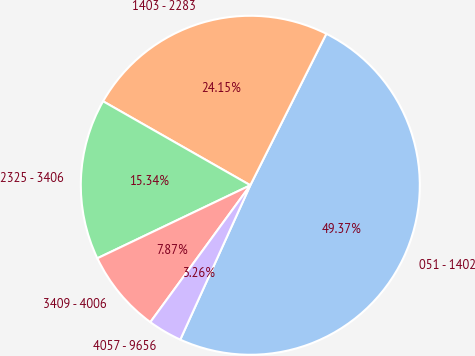Convert chart. <chart><loc_0><loc_0><loc_500><loc_500><pie_chart><fcel>051 - 1402<fcel>1403 - 2283<fcel>2325 - 3406<fcel>3409 - 4006<fcel>4057 - 9656<nl><fcel>49.37%<fcel>24.15%<fcel>15.34%<fcel>7.87%<fcel>3.26%<nl></chart> 